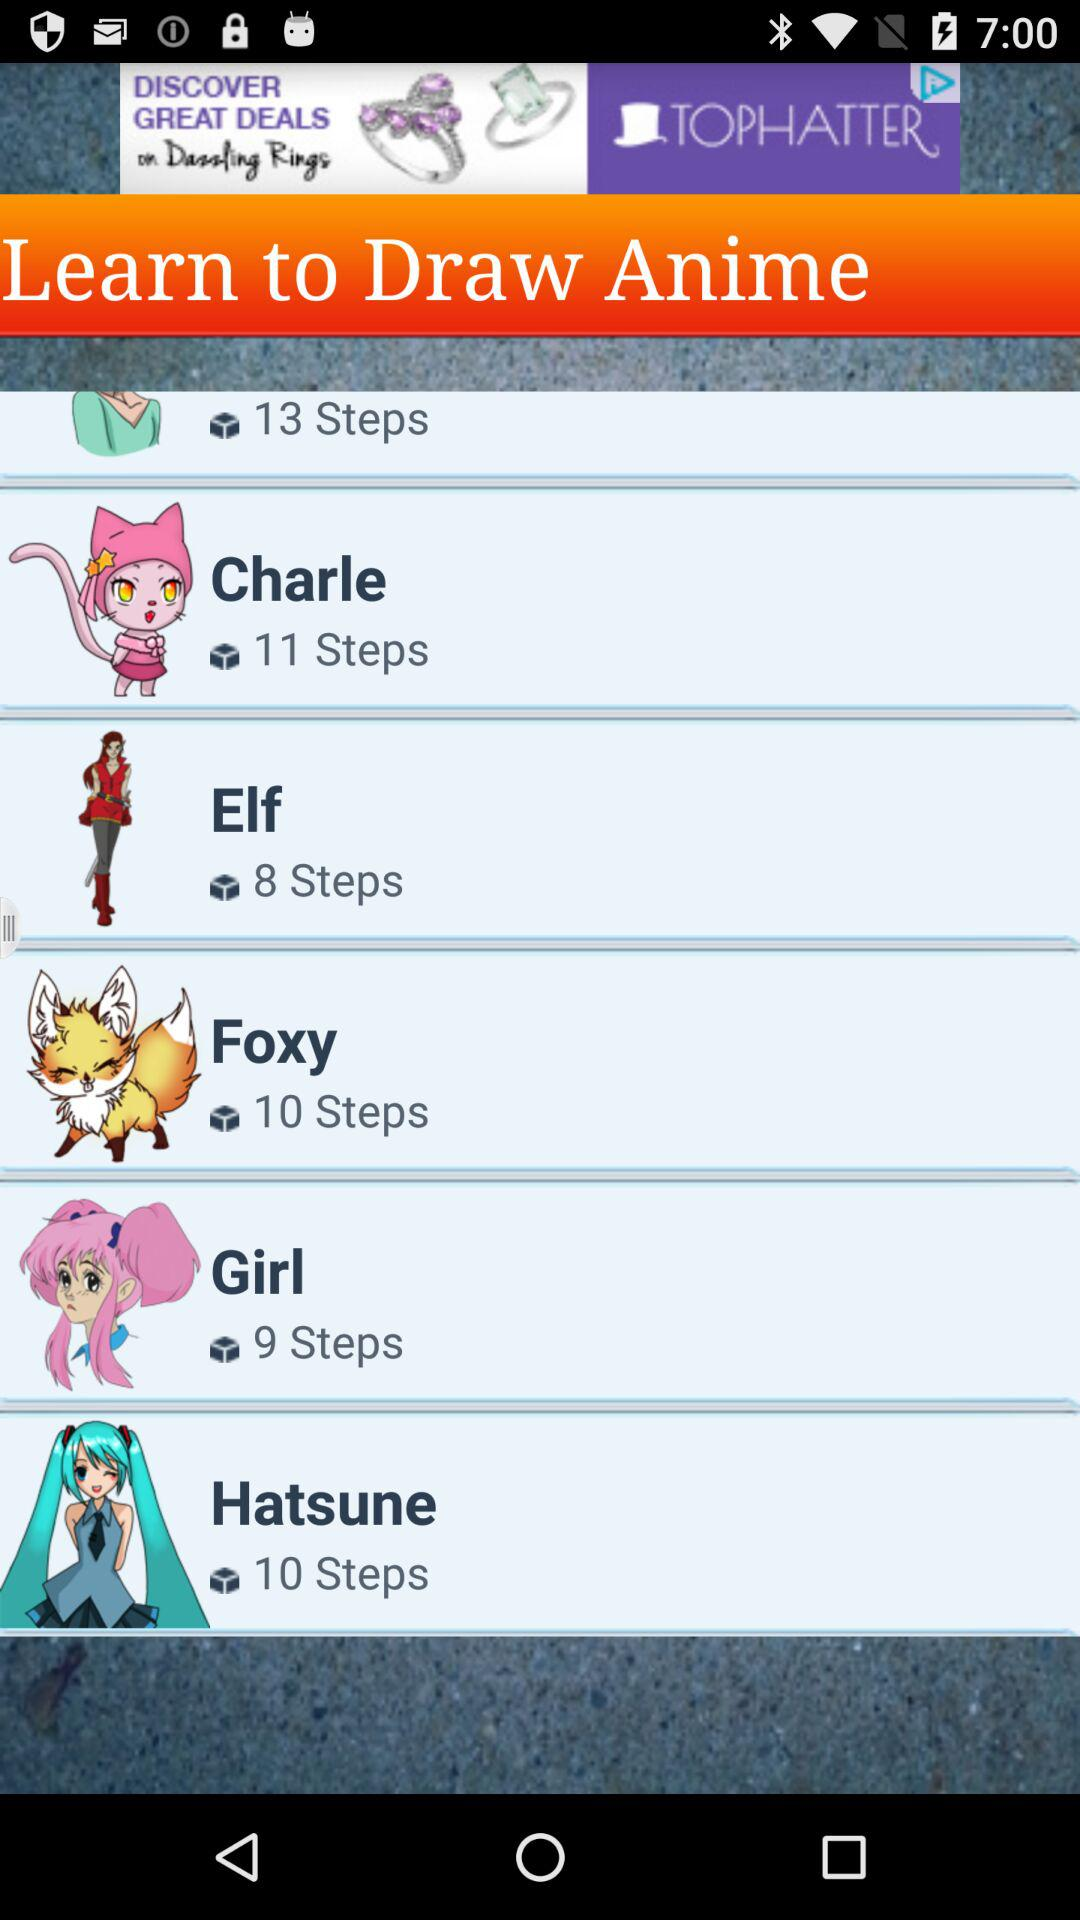What is the name of the anime that has 11 steps? The name of the anime that has 11 steps is "Charle". 